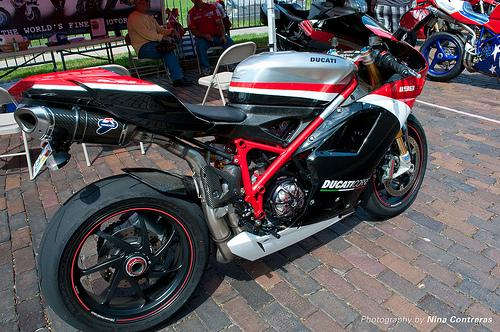What are the people in the image sitting on? People are sitting on metal folding chairs. What is located behind the people in the image? A couple of tables are located behind the people. Describe the surface the motorcycle is parked on. The motorcycle is parked on a glossy brick parking area. Can you identify any special element on the motorcycle tire? The rim of the tire is trimmed in red. Point out some details about the area captured in this image. The area is paved with bricks, has metal folding chairs, and has advertising hanging on a fence. What is the special feature of the tire in the image? The tire is black and has blue spokes. What is the sitting posture of the man in the red shirt? The man has his legs crossed. What type of vehicle is in the foreground of this photograph? A fancy red and silver Ducati motorcycle is in the foreground. How many motorcycles are there in the background of the image? There is a group of motorcycles in the background. Mention the colors of the motorcycle in this image. The motorcycle is black, white, red, and silver. Is the advertising banner about fast food restaurants? The image features an advertising banner, but it is specifically mentioned to be about the world's finest motorcycles, not fast food, making the instruction misleading. Are the people standing and applauding? The captions describe people sitting in chairs and a man sitting on the sidewalk, but there is no mention of people standing or applauding, so this instruction is misleading. Is the motorcycle parked on the grass? The image contains captions that mention a motorcycle on the pavement or sidewalk, but none of them mention it being parked on grass, so the instruction is misleading. Are there any trees or plants visible in the scene? The captions in the image focus on motorcycles, people, chairs, tables, and the pavement, but there is no mention of any trees or plants in the scene, making the instruction misleading. Are the folding chairs made of wood? The captions describe metal folding chairs, not wooden ones. So, mentioning wooden chairs in the instruction is misleading. Is there a large blue car in the background? All the vehicles mentioned in the image are motorcycles, with no mention of a car or the color blue in relation to the vehicles. So, mentioning a blue car is misleading. 